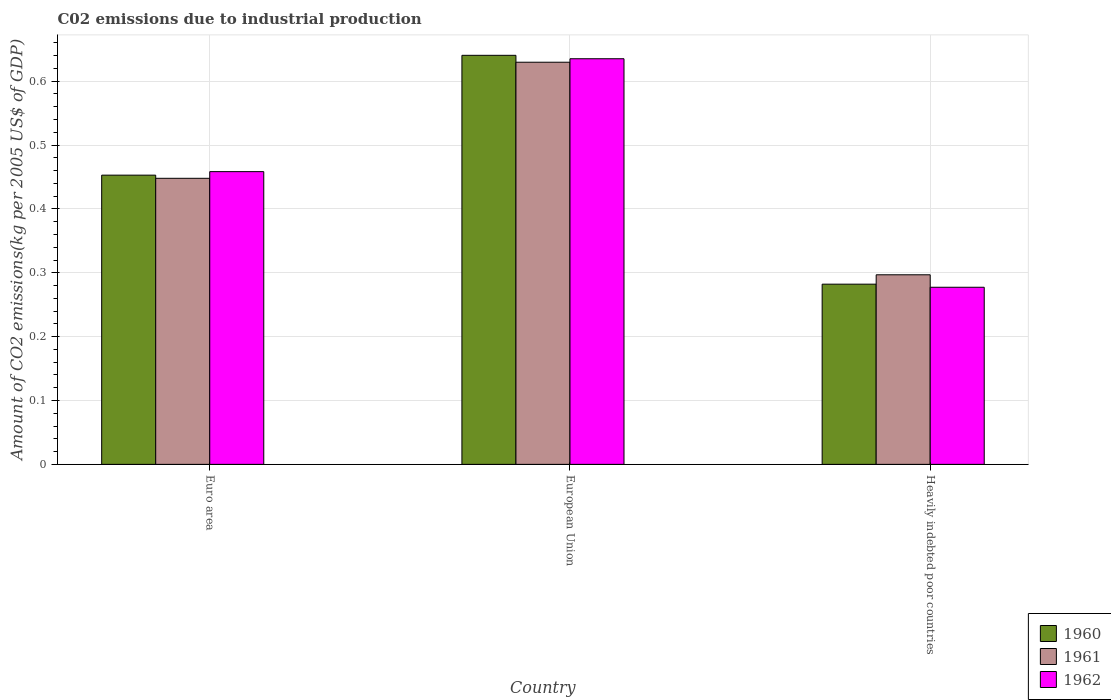How many different coloured bars are there?
Provide a succinct answer. 3. How many groups of bars are there?
Your answer should be compact. 3. What is the label of the 2nd group of bars from the left?
Provide a short and direct response. European Union. What is the amount of CO2 emitted due to industrial production in 1961 in Euro area?
Ensure brevity in your answer.  0.45. Across all countries, what is the maximum amount of CO2 emitted due to industrial production in 1962?
Your answer should be very brief. 0.64. Across all countries, what is the minimum amount of CO2 emitted due to industrial production in 1960?
Ensure brevity in your answer.  0.28. In which country was the amount of CO2 emitted due to industrial production in 1961 maximum?
Offer a terse response. European Union. In which country was the amount of CO2 emitted due to industrial production in 1960 minimum?
Offer a very short reply. Heavily indebted poor countries. What is the total amount of CO2 emitted due to industrial production in 1962 in the graph?
Ensure brevity in your answer.  1.37. What is the difference between the amount of CO2 emitted due to industrial production in 1962 in Euro area and that in European Union?
Keep it short and to the point. -0.18. What is the difference between the amount of CO2 emitted due to industrial production in 1962 in Euro area and the amount of CO2 emitted due to industrial production in 1961 in Heavily indebted poor countries?
Provide a succinct answer. 0.16. What is the average amount of CO2 emitted due to industrial production in 1960 per country?
Ensure brevity in your answer.  0.46. What is the difference between the amount of CO2 emitted due to industrial production of/in 1960 and amount of CO2 emitted due to industrial production of/in 1961 in Euro area?
Ensure brevity in your answer.  0. What is the ratio of the amount of CO2 emitted due to industrial production in 1961 in European Union to that in Heavily indebted poor countries?
Ensure brevity in your answer.  2.12. Is the amount of CO2 emitted due to industrial production in 1962 in Euro area less than that in Heavily indebted poor countries?
Provide a short and direct response. No. Is the difference between the amount of CO2 emitted due to industrial production in 1960 in Euro area and European Union greater than the difference between the amount of CO2 emitted due to industrial production in 1961 in Euro area and European Union?
Your answer should be very brief. No. What is the difference between the highest and the second highest amount of CO2 emitted due to industrial production in 1960?
Your answer should be compact. 0.19. What is the difference between the highest and the lowest amount of CO2 emitted due to industrial production in 1960?
Give a very brief answer. 0.36. Is the sum of the amount of CO2 emitted due to industrial production in 1962 in European Union and Heavily indebted poor countries greater than the maximum amount of CO2 emitted due to industrial production in 1960 across all countries?
Give a very brief answer. Yes. What does the 2nd bar from the left in Euro area represents?
Your response must be concise. 1961. What does the 1st bar from the right in Heavily indebted poor countries represents?
Provide a succinct answer. 1962. How many bars are there?
Your answer should be compact. 9. How many countries are there in the graph?
Make the answer very short. 3. What is the difference between two consecutive major ticks on the Y-axis?
Offer a terse response. 0.1. Does the graph contain any zero values?
Provide a succinct answer. No. Does the graph contain grids?
Your answer should be compact. Yes. Where does the legend appear in the graph?
Your answer should be compact. Bottom right. What is the title of the graph?
Provide a succinct answer. C02 emissions due to industrial production. Does "1987" appear as one of the legend labels in the graph?
Keep it short and to the point. No. What is the label or title of the Y-axis?
Give a very brief answer. Amount of CO2 emissions(kg per 2005 US$ of GDP). What is the Amount of CO2 emissions(kg per 2005 US$ of GDP) of 1960 in Euro area?
Ensure brevity in your answer.  0.45. What is the Amount of CO2 emissions(kg per 2005 US$ of GDP) of 1961 in Euro area?
Your answer should be compact. 0.45. What is the Amount of CO2 emissions(kg per 2005 US$ of GDP) of 1962 in Euro area?
Offer a very short reply. 0.46. What is the Amount of CO2 emissions(kg per 2005 US$ of GDP) of 1960 in European Union?
Offer a terse response. 0.64. What is the Amount of CO2 emissions(kg per 2005 US$ of GDP) in 1961 in European Union?
Provide a succinct answer. 0.63. What is the Amount of CO2 emissions(kg per 2005 US$ of GDP) in 1962 in European Union?
Offer a very short reply. 0.64. What is the Amount of CO2 emissions(kg per 2005 US$ of GDP) of 1960 in Heavily indebted poor countries?
Offer a terse response. 0.28. What is the Amount of CO2 emissions(kg per 2005 US$ of GDP) in 1961 in Heavily indebted poor countries?
Give a very brief answer. 0.3. What is the Amount of CO2 emissions(kg per 2005 US$ of GDP) in 1962 in Heavily indebted poor countries?
Ensure brevity in your answer.  0.28. Across all countries, what is the maximum Amount of CO2 emissions(kg per 2005 US$ of GDP) of 1960?
Make the answer very short. 0.64. Across all countries, what is the maximum Amount of CO2 emissions(kg per 2005 US$ of GDP) of 1961?
Give a very brief answer. 0.63. Across all countries, what is the maximum Amount of CO2 emissions(kg per 2005 US$ of GDP) in 1962?
Your answer should be compact. 0.64. Across all countries, what is the minimum Amount of CO2 emissions(kg per 2005 US$ of GDP) of 1960?
Make the answer very short. 0.28. Across all countries, what is the minimum Amount of CO2 emissions(kg per 2005 US$ of GDP) of 1961?
Your answer should be very brief. 0.3. Across all countries, what is the minimum Amount of CO2 emissions(kg per 2005 US$ of GDP) in 1962?
Your answer should be very brief. 0.28. What is the total Amount of CO2 emissions(kg per 2005 US$ of GDP) of 1960 in the graph?
Make the answer very short. 1.38. What is the total Amount of CO2 emissions(kg per 2005 US$ of GDP) in 1961 in the graph?
Make the answer very short. 1.37. What is the total Amount of CO2 emissions(kg per 2005 US$ of GDP) of 1962 in the graph?
Provide a succinct answer. 1.37. What is the difference between the Amount of CO2 emissions(kg per 2005 US$ of GDP) in 1960 in Euro area and that in European Union?
Your response must be concise. -0.19. What is the difference between the Amount of CO2 emissions(kg per 2005 US$ of GDP) of 1961 in Euro area and that in European Union?
Provide a succinct answer. -0.18. What is the difference between the Amount of CO2 emissions(kg per 2005 US$ of GDP) of 1962 in Euro area and that in European Union?
Keep it short and to the point. -0.18. What is the difference between the Amount of CO2 emissions(kg per 2005 US$ of GDP) of 1960 in Euro area and that in Heavily indebted poor countries?
Ensure brevity in your answer.  0.17. What is the difference between the Amount of CO2 emissions(kg per 2005 US$ of GDP) of 1961 in Euro area and that in Heavily indebted poor countries?
Provide a short and direct response. 0.15. What is the difference between the Amount of CO2 emissions(kg per 2005 US$ of GDP) of 1962 in Euro area and that in Heavily indebted poor countries?
Provide a short and direct response. 0.18. What is the difference between the Amount of CO2 emissions(kg per 2005 US$ of GDP) in 1960 in European Union and that in Heavily indebted poor countries?
Offer a very short reply. 0.36. What is the difference between the Amount of CO2 emissions(kg per 2005 US$ of GDP) in 1961 in European Union and that in Heavily indebted poor countries?
Offer a terse response. 0.33. What is the difference between the Amount of CO2 emissions(kg per 2005 US$ of GDP) in 1962 in European Union and that in Heavily indebted poor countries?
Provide a short and direct response. 0.36. What is the difference between the Amount of CO2 emissions(kg per 2005 US$ of GDP) in 1960 in Euro area and the Amount of CO2 emissions(kg per 2005 US$ of GDP) in 1961 in European Union?
Provide a succinct answer. -0.18. What is the difference between the Amount of CO2 emissions(kg per 2005 US$ of GDP) in 1960 in Euro area and the Amount of CO2 emissions(kg per 2005 US$ of GDP) in 1962 in European Union?
Give a very brief answer. -0.18. What is the difference between the Amount of CO2 emissions(kg per 2005 US$ of GDP) of 1961 in Euro area and the Amount of CO2 emissions(kg per 2005 US$ of GDP) of 1962 in European Union?
Offer a terse response. -0.19. What is the difference between the Amount of CO2 emissions(kg per 2005 US$ of GDP) of 1960 in Euro area and the Amount of CO2 emissions(kg per 2005 US$ of GDP) of 1961 in Heavily indebted poor countries?
Give a very brief answer. 0.16. What is the difference between the Amount of CO2 emissions(kg per 2005 US$ of GDP) of 1960 in Euro area and the Amount of CO2 emissions(kg per 2005 US$ of GDP) of 1962 in Heavily indebted poor countries?
Your response must be concise. 0.18. What is the difference between the Amount of CO2 emissions(kg per 2005 US$ of GDP) in 1961 in Euro area and the Amount of CO2 emissions(kg per 2005 US$ of GDP) in 1962 in Heavily indebted poor countries?
Offer a very short reply. 0.17. What is the difference between the Amount of CO2 emissions(kg per 2005 US$ of GDP) of 1960 in European Union and the Amount of CO2 emissions(kg per 2005 US$ of GDP) of 1961 in Heavily indebted poor countries?
Provide a short and direct response. 0.34. What is the difference between the Amount of CO2 emissions(kg per 2005 US$ of GDP) in 1960 in European Union and the Amount of CO2 emissions(kg per 2005 US$ of GDP) in 1962 in Heavily indebted poor countries?
Your answer should be compact. 0.36. What is the difference between the Amount of CO2 emissions(kg per 2005 US$ of GDP) in 1961 in European Union and the Amount of CO2 emissions(kg per 2005 US$ of GDP) in 1962 in Heavily indebted poor countries?
Ensure brevity in your answer.  0.35. What is the average Amount of CO2 emissions(kg per 2005 US$ of GDP) of 1960 per country?
Make the answer very short. 0.46. What is the average Amount of CO2 emissions(kg per 2005 US$ of GDP) in 1961 per country?
Ensure brevity in your answer.  0.46. What is the average Amount of CO2 emissions(kg per 2005 US$ of GDP) in 1962 per country?
Your answer should be compact. 0.46. What is the difference between the Amount of CO2 emissions(kg per 2005 US$ of GDP) of 1960 and Amount of CO2 emissions(kg per 2005 US$ of GDP) of 1961 in Euro area?
Keep it short and to the point. 0. What is the difference between the Amount of CO2 emissions(kg per 2005 US$ of GDP) of 1960 and Amount of CO2 emissions(kg per 2005 US$ of GDP) of 1962 in Euro area?
Offer a very short reply. -0.01. What is the difference between the Amount of CO2 emissions(kg per 2005 US$ of GDP) in 1961 and Amount of CO2 emissions(kg per 2005 US$ of GDP) in 1962 in Euro area?
Make the answer very short. -0.01. What is the difference between the Amount of CO2 emissions(kg per 2005 US$ of GDP) of 1960 and Amount of CO2 emissions(kg per 2005 US$ of GDP) of 1961 in European Union?
Ensure brevity in your answer.  0.01. What is the difference between the Amount of CO2 emissions(kg per 2005 US$ of GDP) of 1960 and Amount of CO2 emissions(kg per 2005 US$ of GDP) of 1962 in European Union?
Make the answer very short. 0.01. What is the difference between the Amount of CO2 emissions(kg per 2005 US$ of GDP) in 1961 and Amount of CO2 emissions(kg per 2005 US$ of GDP) in 1962 in European Union?
Offer a very short reply. -0.01. What is the difference between the Amount of CO2 emissions(kg per 2005 US$ of GDP) in 1960 and Amount of CO2 emissions(kg per 2005 US$ of GDP) in 1961 in Heavily indebted poor countries?
Provide a succinct answer. -0.01. What is the difference between the Amount of CO2 emissions(kg per 2005 US$ of GDP) of 1960 and Amount of CO2 emissions(kg per 2005 US$ of GDP) of 1962 in Heavily indebted poor countries?
Your response must be concise. 0. What is the difference between the Amount of CO2 emissions(kg per 2005 US$ of GDP) in 1961 and Amount of CO2 emissions(kg per 2005 US$ of GDP) in 1962 in Heavily indebted poor countries?
Give a very brief answer. 0.02. What is the ratio of the Amount of CO2 emissions(kg per 2005 US$ of GDP) in 1960 in Euro area to that in European Union?
Give a very brief answer. 0.71. What is the ratio of the Amount of CO2 emissions(kg per 2005 US$ of GDP) in 1961 in Euro area to that in European Union?
Provide a succinct answer. 0.71. What is the ratio of the Amount of CO2 emissions(kg per 2005 US$ of GDP) of 1962 in Euro area to that in European Union?
Offer a terse response. 0.72. What is the ratio of the Amount of CO2 emissions(kg per 2005 US$ of GDP) in 1960 in Euro area to that in Heavily indebted poor countries?
Ensure brevity in your answer.  1.6. What is the ratio of the Amount of CO2 emissions(kg per 2005 US$ of GDP) in 1961 in Euro area to that in Heavily indebted poor countries?
Provide a succinct answer. 1.51. What is the ratio of the Amount of CO2 emissions(kg per 2005 US$ of GDP) of 1962 in Euro area to that in Heavily indebted poor countries?
Offer a very short reply. 1.65. What is the ratio of the Amount of CO2 emissions(kg per 2005 US$ of GDP) of 1960 in European Union to that in Heavily indebted poor countries?
Your answer should be very brief. 2.27. What is the ratio of the Amount of CO2 emissions(kg per 2005 US$ of GDP) in 1961 in European Union to that in Heavily indebted poor countries?
Offer a terse response. 2.12. What is the ratio of the Amount of CO2 emissions(kg per 2005 US$ of GDP) in 1962 in European Union to that in Heavily indebted poor countries?
Ensure brevity in your answer.  2.29. What is the difference between the highest and the second highest Amount of CO2 emissions(kg per 2005 US$ of GDP) in 1960?
Give a very brief answer. 0.19. What is the difference between the highest and the second highest Amount of CO2 emissions(kg per 2005 US$ of GDP) of 1961?
Ensure brevity in your answer.  0.18. What is the difference between the highest and the second highest Amount of CO2 emissions(kg per 2005 US$ of GDP) of 1962?
Make the answer very short. 0.18. What is the difference between the highest and the lowest Amount of CO2 emissions(kg per 2005 US$ of GDP) in 1960?
Ensure brevity in your answer.  0.36. What is the difference between the highest and the lowest Amount of CO2 emissions(kg per 2005 US$ of GDP) in 1961?
Your response must be concise. 0.33. What is the difference between the highest and the lowest Amount of CO2 emissions(kg per 2005 US$ of GDP) in 1962?
Offer a very short reply. 0.36. 